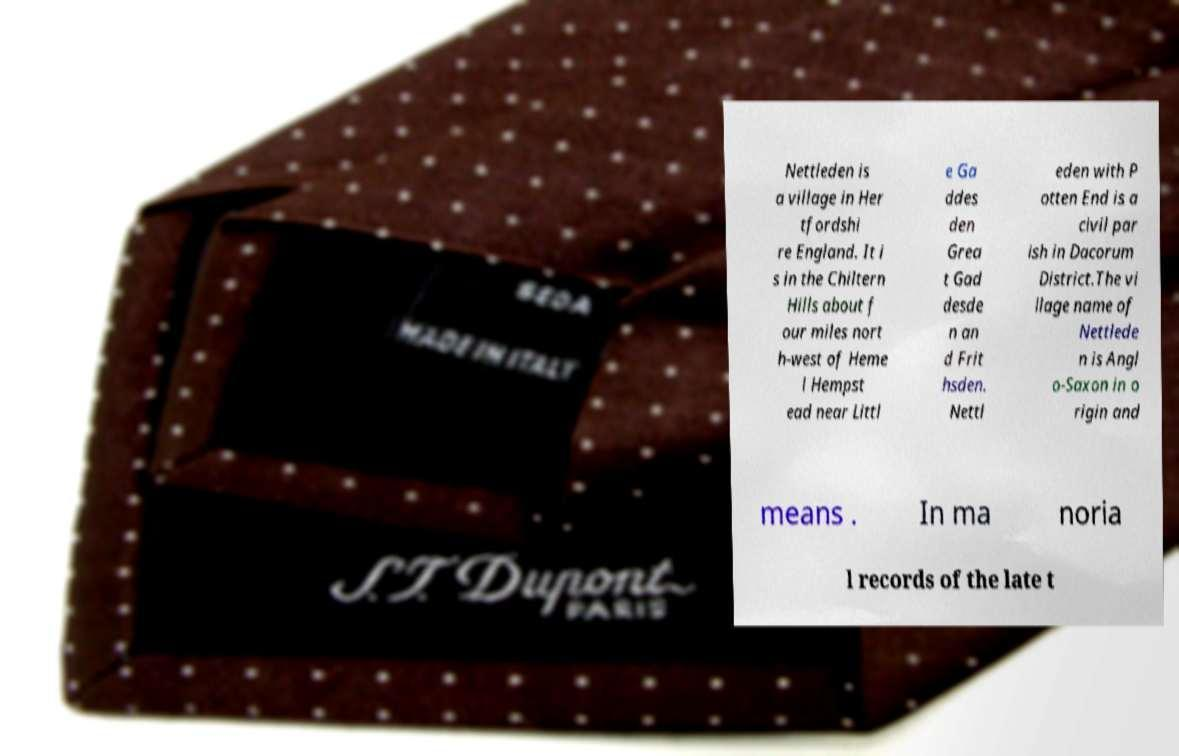I need the written content from this picture converted into text. Can you do that? Nettleden is a village in Her tfordshi re England. It i s in the Chiltern Hills about f our miles nort h-west of Heme l Hempst ead near Littl e Ga ddes den Grea t Gad desde n an d Frit hsden. Nettl eden with P otten End is a civil par ish in Dacorum District.The vi llage name of Nettlede n is Angl o-Saxon in o rigin and means . In ma noria l records of the late t 